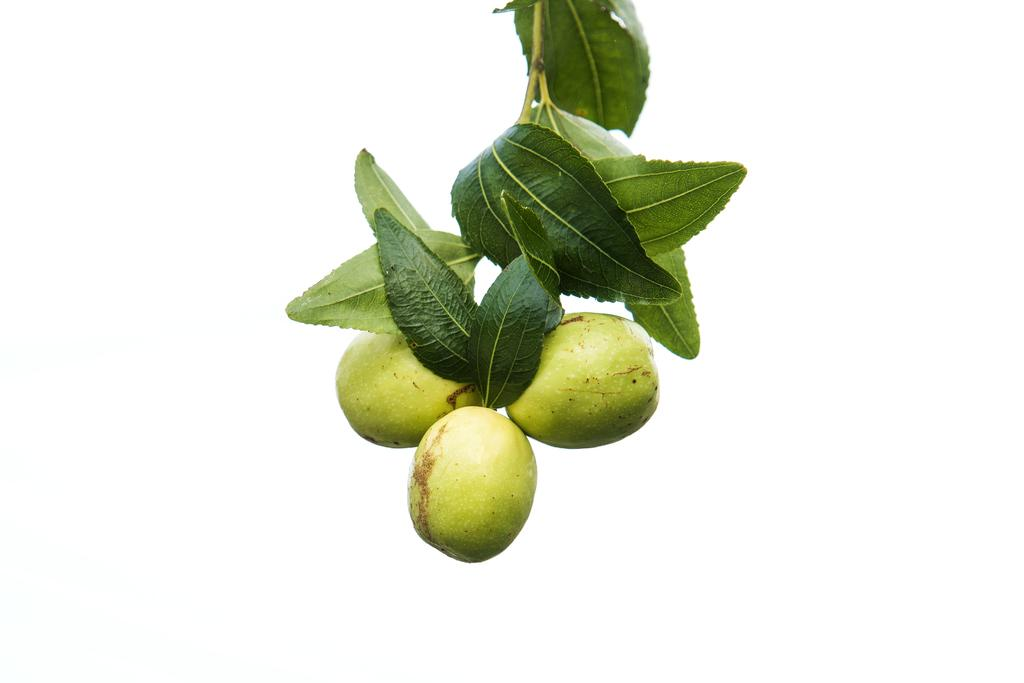What is located in the center of the image? There are fruits and leaves in the center of the image. Can you describe the fruits in the image? The provided facts do not specify the type of fruits in the image. What else is present in the center of the image besides the fruits? There are leaves in the center of the image. Is the roof of the house visible in the image? There is no mention of a house or roof in the provided facts, so it cannot be determined if the roof is visible in the image. 